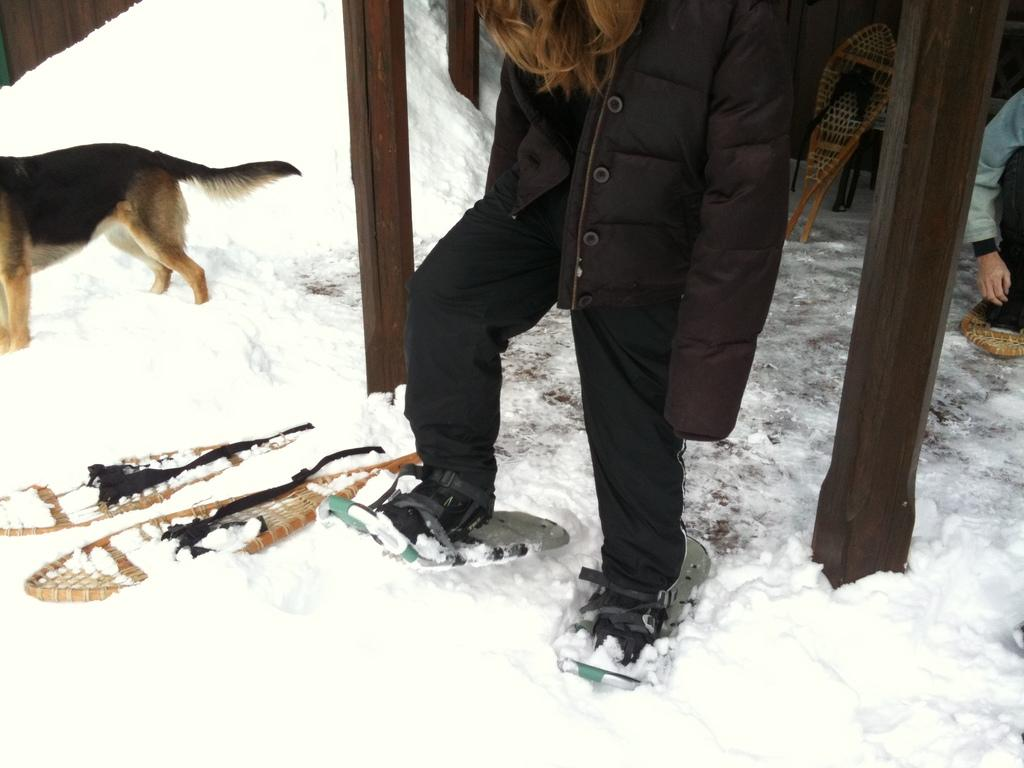What is the person in the image wearing? The person in the image is wearing a ski-board. Can you describe any other objects in the image? There are objects in the image, but their specific details are not mentioned in the facts. What type of natural environment is visible in the image? There is snow visible in the image, indicating a winter or snowy environment. What kind of animal can be seen in the image? There is an animal with brown and black color in the image. What type of jam is being spread on the bread in the image? There is no bread or jam present in the image; it features a person wearing a ski-board, snow, and an animal with brown and black color. 